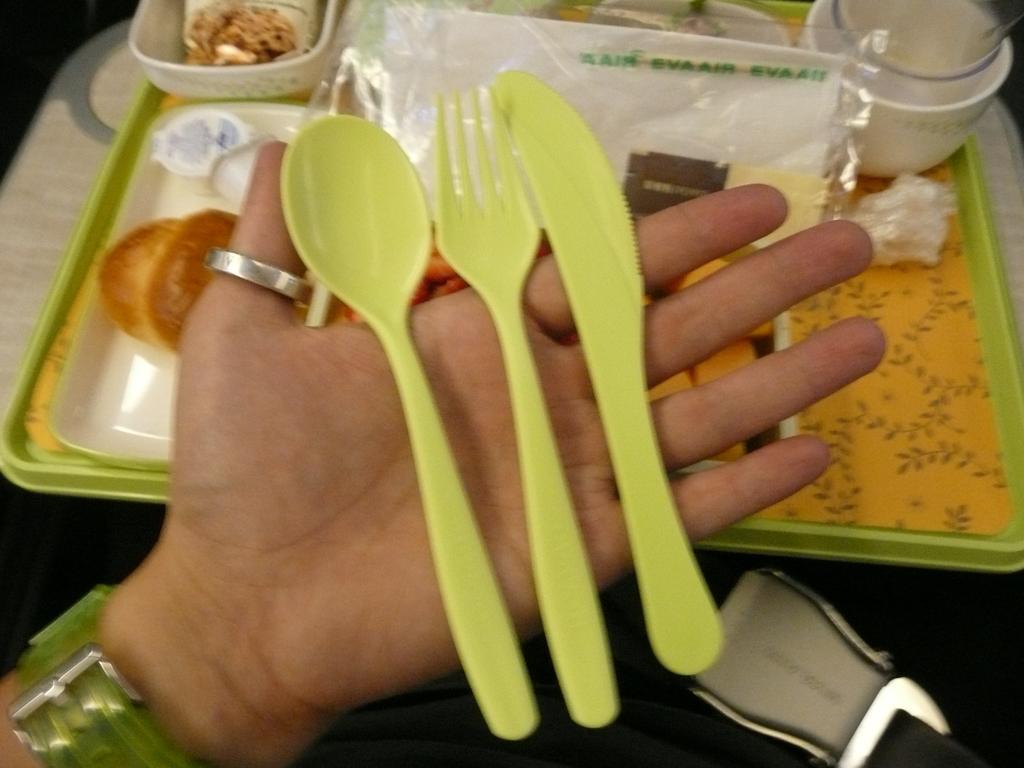Please provide a concise description of this image. In this picture we can see a plastic spoon, fork in hand and also we can see cups in a tray. 